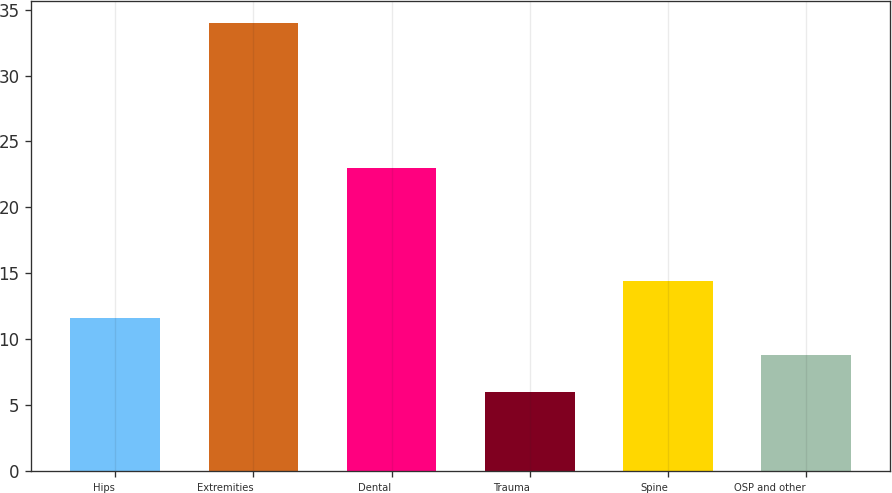Convert chart to OTSL. <chart><loc_0><loc_0><loc_500><loc_500><bar_chart><fcel>Hips<fcel>Extremities<fcel>Dental<fcel>Trauma<fcel>Spine<fcel>OSP and other<nl><fcel>11.6<fcel>34<fcel>23<fcel>6<fcel>14.4<fcel>8.8<nl></chart> 